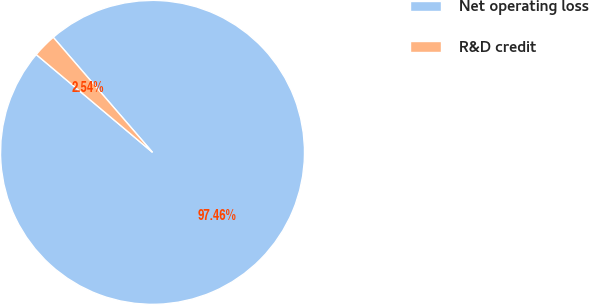Convert chart. <chart><loc_0><loc_0><loc_500><loc_500><pie_chart><fcel>Net operating loss<fcel>R&D credit<nl><fcel>97.46%<fcel>2.54%<nl></chart> 